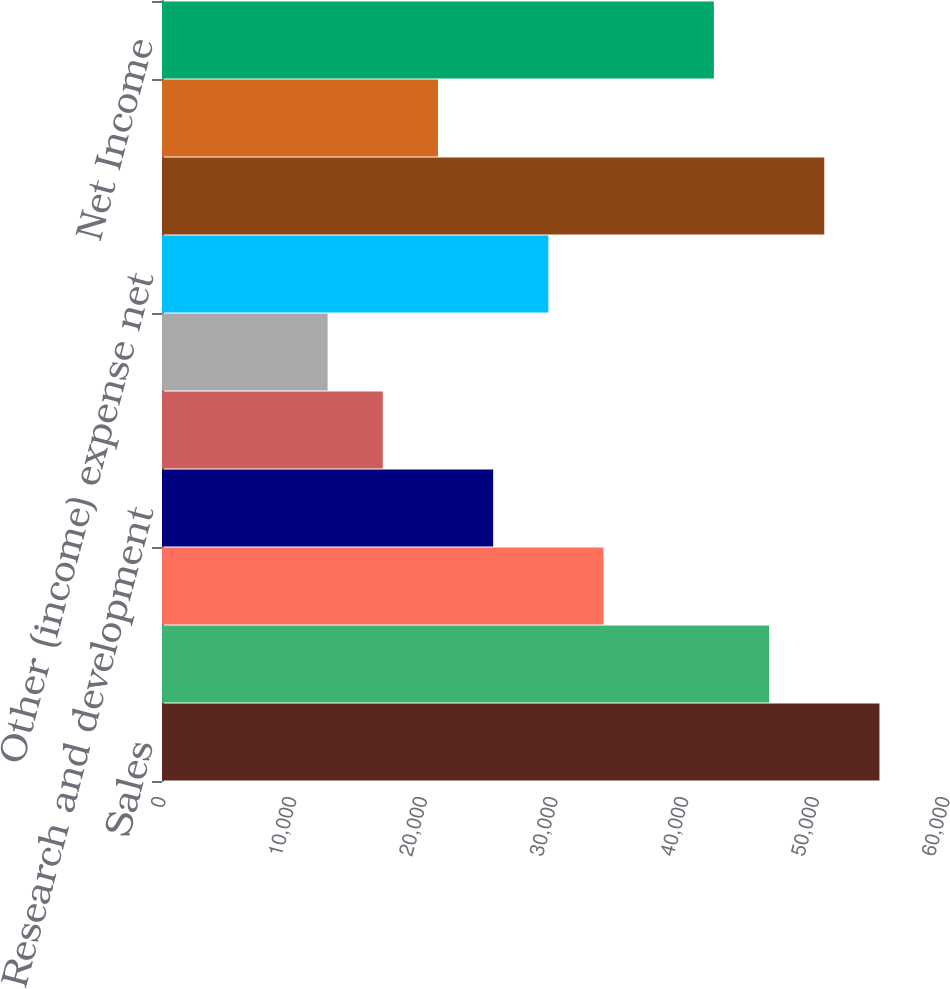Convert chart to OTSL. <chart><loc_0><loc_0><loc_500><loc_500><bar_chart><fcel>Sales<fcel>Materials and production<fcel>Marketing and administrative<fcel>Research and development<fcel>Restructuring costs<fcel>Equity income from affiliates<fcel>Other (income) expense net<fcel>Income Before Taxes<fcel>Taxes on Income<fcel>Net Income<nl><fcel>54906.8<fcel>46460.3<fcel>33790.4<fcel>25343.8<fcel>16897.2<fcel>12673.9<fcel>29567.1<fcel>50683.6<fcel>21120.5<fcel>42237<nl></chart> 